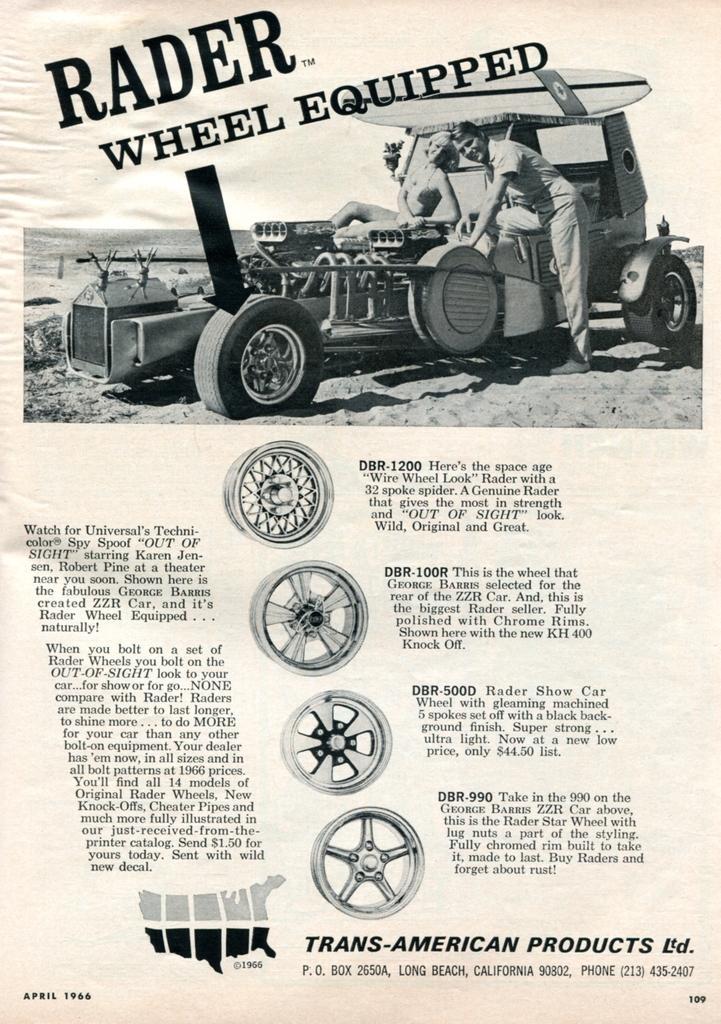Could you give a brief overview of what you see in this image? In this picture we can see a man, woman and a vehicle. There are wheels, some text and numbers. 